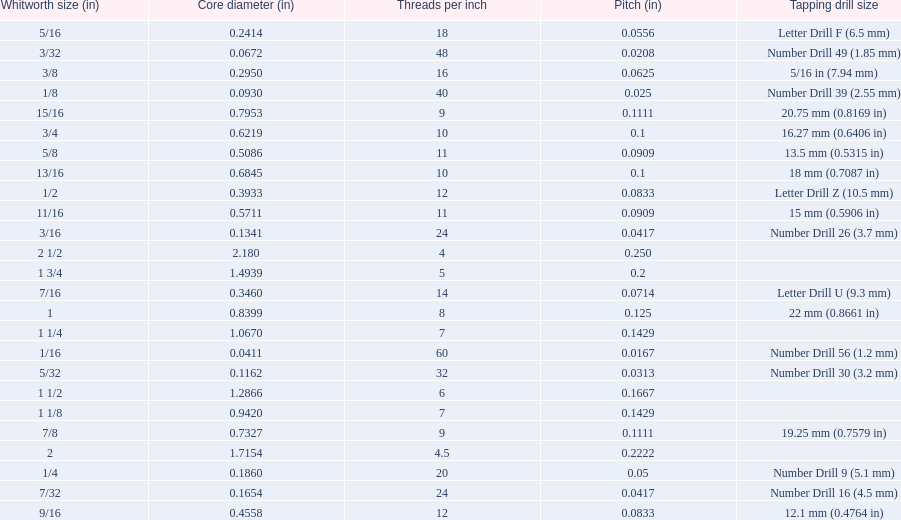What are the sizes of threads per inch? 60, 48, 40, 32, 24, 24, 20, 18, 16, 14, 12, 12, 11, 11, 10, 10, 9, 9, 8, 7, 7, 6, 5, 4.5, 4. Which whitworth size has only 5 threads per inch? 1 3/4. 